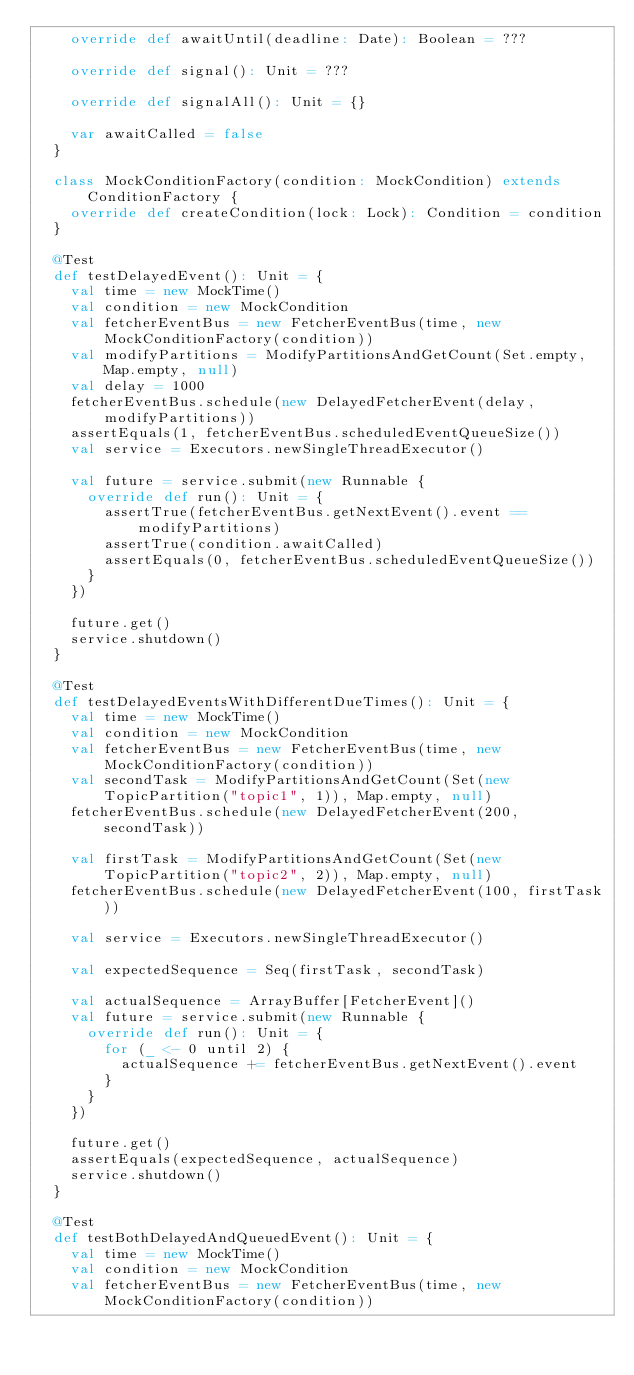<code> <loc_0><loc_0><loc_500><loc_500><_Scala_>    override def awaitUntil(deadline: Date): Boolean = ???

    override def signal(): Unit = ???

    override def signalAll(): Unit = {}

    var awaitCalled = false
  }

  class MockConditionFactory(condition: MockCondition) extends ConditionFactory {
    override def createCondition(lock: Lock): Condition = condition
  }

  @Test
  def testDelayedEvent(): Unit = {
    val time = new MockTime()
    val condition = new MockCondition
    val fetcherEventBus = new FetcherEventBus(time, new MockConditionFactory(condition))
    val modifyPartitions = ModifyPartitionsAndGetCount(Set.empty, Map.empty, null)
    val delay = 1000
    fetcherEventBus.schedule(new DelayedFetcherEvent(delay, modifyPartitions))
    assertEquals(1, fetcherEventBus.scheduledEventQueueSize())
    val service = Executors.newSingleThreadExecutor()

    val future = service.submit(new Runnable {
      override def run(): Unit = {
        assertTrue(fetcherEventBus.getNextEvent().event == modifyPartitions)
        assertTrue(condition.awaitCalled)
        assertEquals(0, fetcherEventBus.scheduledEventQueueSize())
      }
    })

    future.get()
    service.shutdown()
  }

  @Test
  def testDelayedEventsWithDifferentDueTimes(): Unit = {
    val time = new MockTime()
    val condition = new MockCondition
    val fetcherEventBus = new FetcherEventBus(time, new MockConditionFactory(condition))
    val secondTask = ModifyPartitionsAndGetCount(Set(new TopicPartition("topic1", 1)), Map.empty, null)
    fetcherEventBus.schedule(new DelayedFetcherEvent(200, secondTask))

    val firstTask = ModifyPartitionsAndGetCount(Set(new TopicPartition("topic2", 2)), Map.empty, null)
    fetcherEventBus.schedule(new DelayedFetcherEvent(100, firstTask))

    val service = Executors.newSingleThreadExecutor()

    val expectedSequence = Seq(firstTask, secondTask)

    val actualSequence = ArrayBuffer[FetcherEvent]()
    val future = service.submit(new Runnable {
      override def run(): Unit = {
        for (_ <- 0 until 2) {
          actualSequence += fetcherEventBus.getNextEvent().event
        }
      }
    })

    future.get()
    assertEquals(expectedSequence, actualSequence)
    service.shutdown()
  }

  @Test
  def testBothDelayedAndQueuedEvent(): Unit = {
    val time = new MockTime()
    val condition = new MockCondition
    val fetcherEventBus = new FetcherEventBus(time, new MockConditionFactory(condition))
</code> 